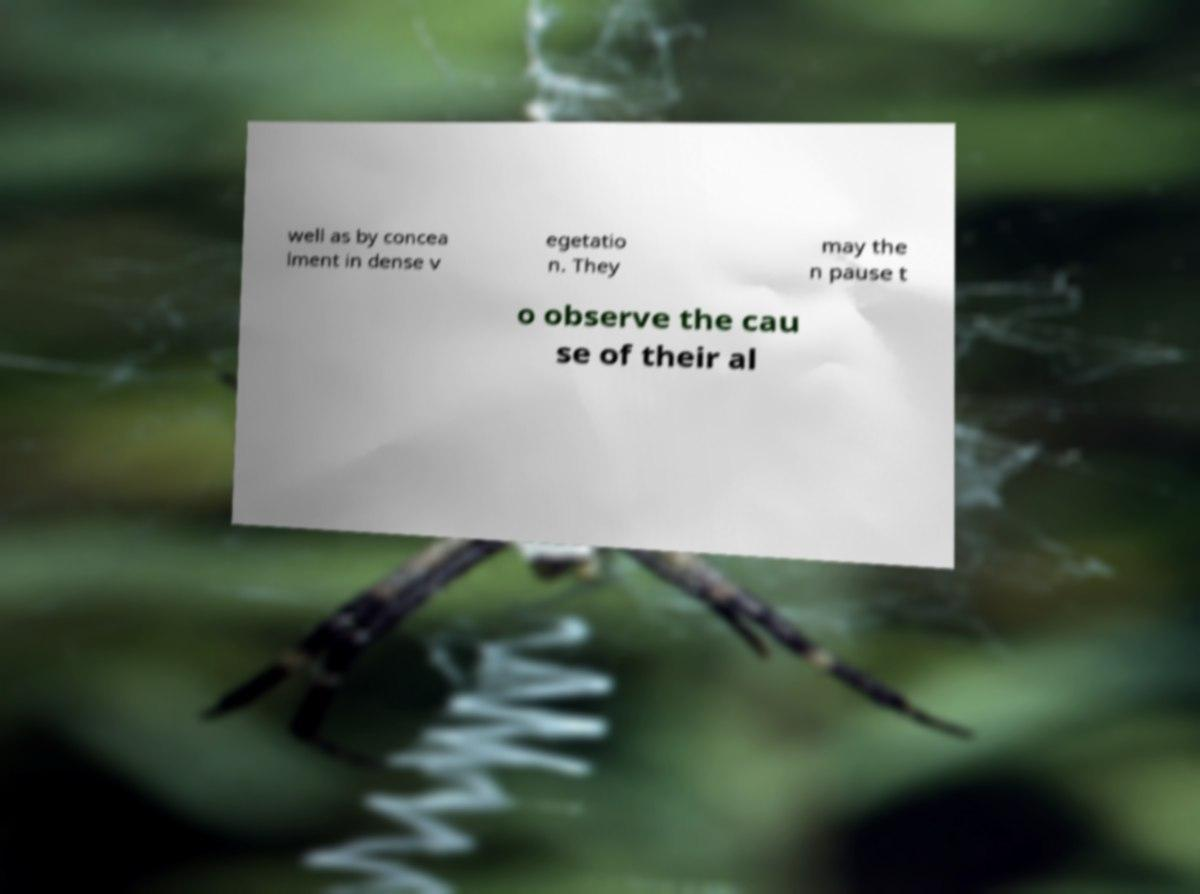Can you accurately transcribe the text from the provided image for me? well as by concea lment in dense v egetatio n. They may the n pause t o observe the cau se of their al 